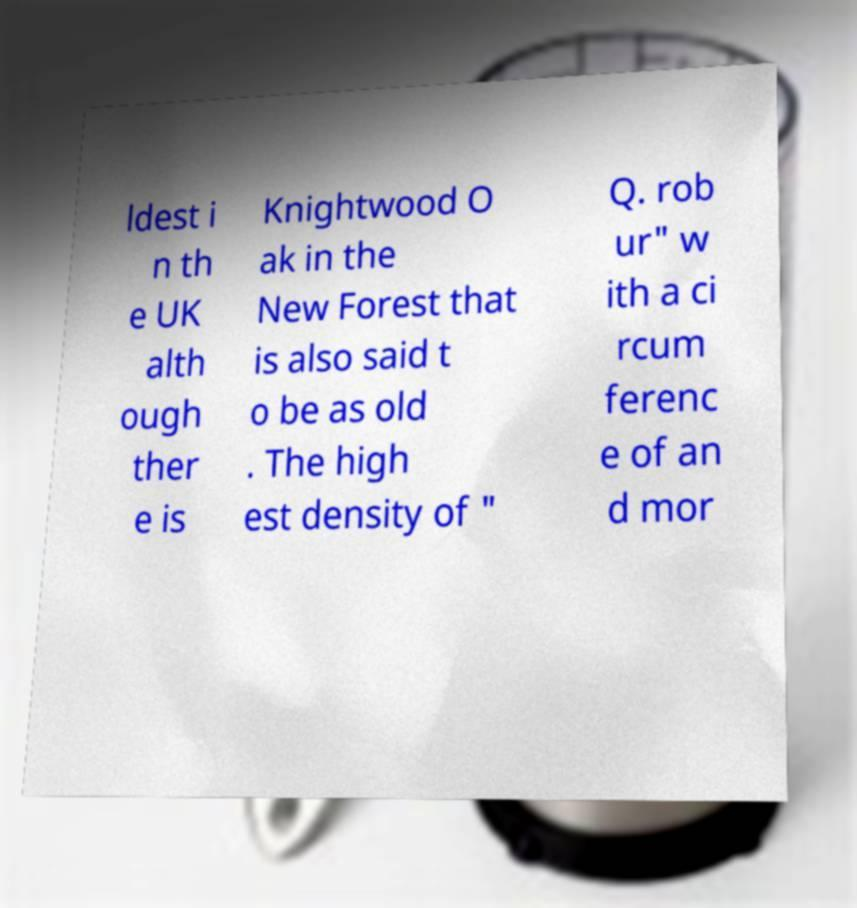Please read and relay the text visible in this image. What does it say? ldest i n th e UK alth ough ther e is Knightwood O ak in the New Forest that is also said t o be as old . The high est density of " Q. rob ur" w ith a ci rcum ferenc e of an d mor 